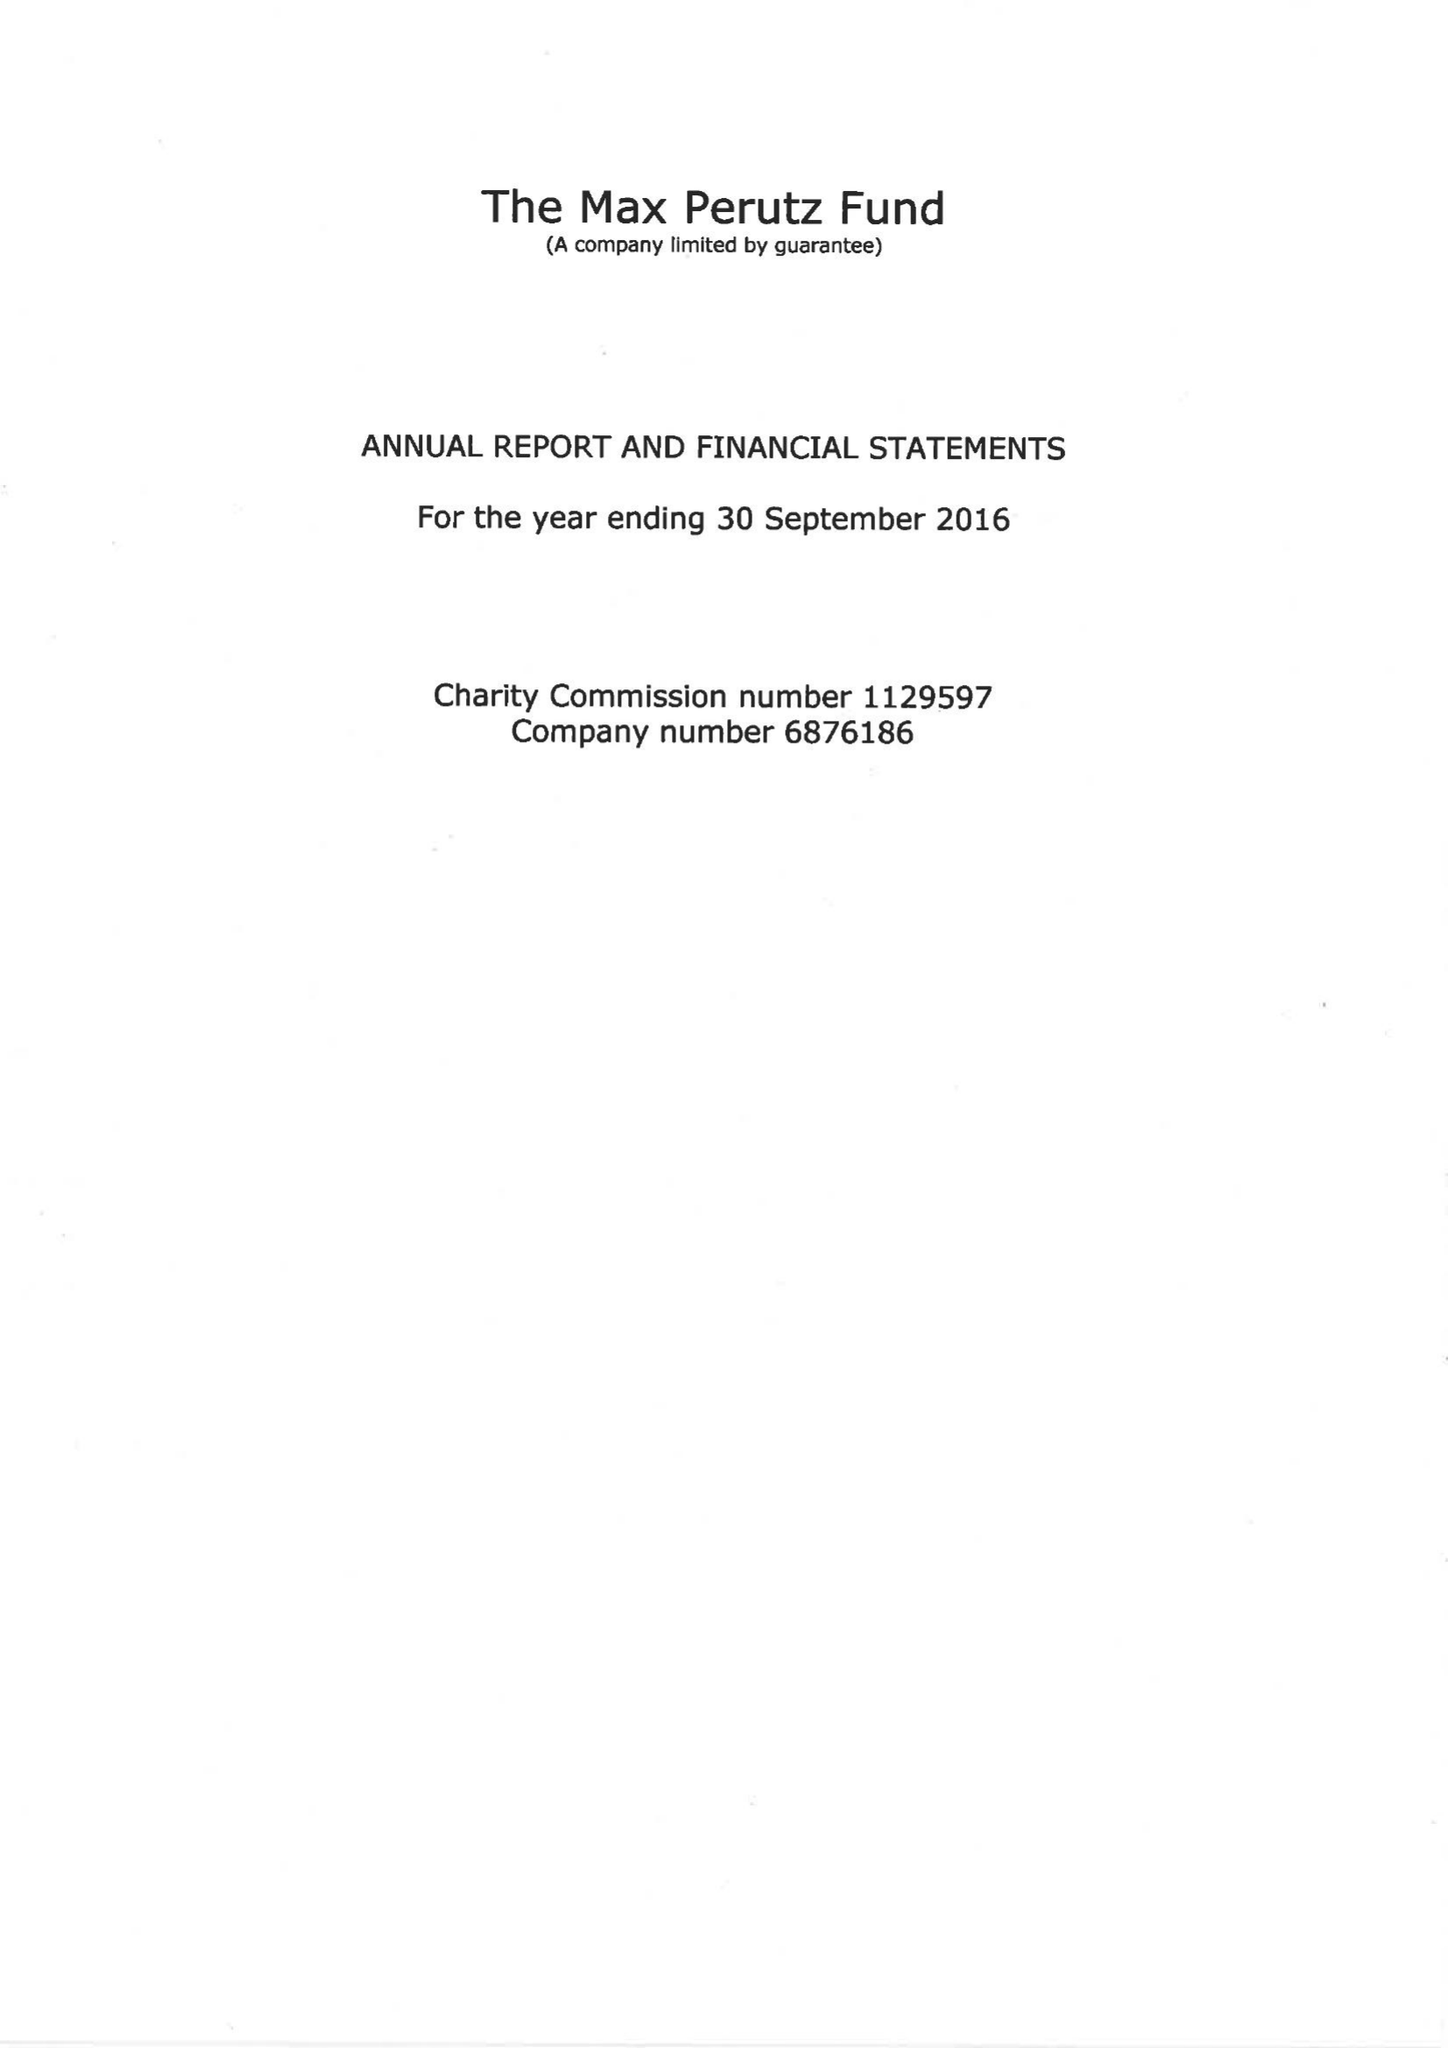What is the value for the spending_annually_in_british_pounds?
Answer the question using a single word or phrase. 90918.00 